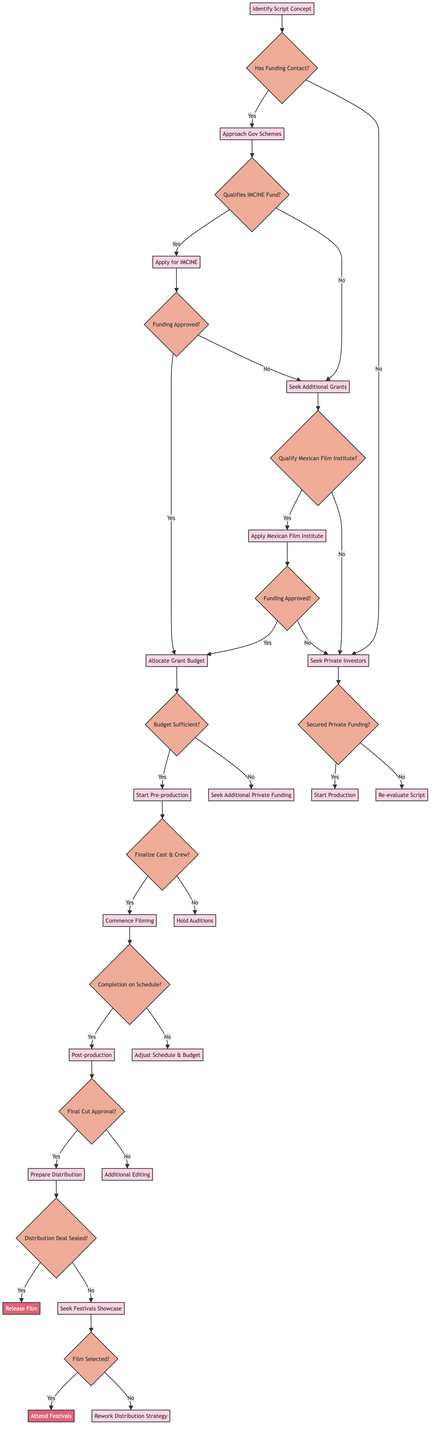What is the first decision node in the diagram? The first decision node is labeled "Has Funding Contact?". This can be identified as it is the first decision branching from the start node, "Identify Script Concept".
Answer: Has Funding Contact? What happens if funding is approved after applying for IMCINE? If funding is approved after applying for IMCINE, the next step is to "Allocate Grant Budget". This is derived directly from the decision point following the application.
Answer: Allocate Grant Budget How many decision nodes are in the diagram? The diagram contains a total of 10 decision nodes. Each branching point indicates a question that needs to be answered to proceed to the next part of the process.
Answer: 10 What is the outcome if additional editing is needed? If "Additional Editing" is required, the process does not continue to distribution but rather indicates that further work is necessary before preparing for distribution. This is shown as a consequence of the decision at the final cut approval stage.
Answer: Additional Editing What must be true for a film to proceed to "Release Film"? For a film to proceed to "Release Film", the "Distribution Deal Sealed?" decision must be "Yes". This indicates that the necessary distribution agreements have been finalized.
Answer: Yes What is the next step after "Start Pre-production" if the cast and crew are not finalized? If the cast and crew are not finalized after "Start Pre-production", the next step is to "Hold Auditions". This follows directly from the decision node asking if the cast and crew are confirmed.
Answer: Hold Auditions What happens if private funding is not secured? If private funding is not secured, the filmmakers are prompted to "Re-evaluate Script". This is the process designed to reconsider the film's concept in the absence of adequate funding.
Answer: Re-evaluate Script How does the decision to apply for the Mexican Film Institute relate to government funding schemes? If the project does not qualify for the IMCINE Fund, the next consideration is whether the production qualifies for the Mexican Film Institute. This creates a pathway from seeking additional grants to potential government support.
Answer: Apply Mexican Film Institute What is the final action taken if the film is selected at festivals? If the film is selected at festivals, the action taken is to "Attend Festivals". This step directly follows the selection decision in the process of preparing for distribution.
Answer: Attend Festivals 